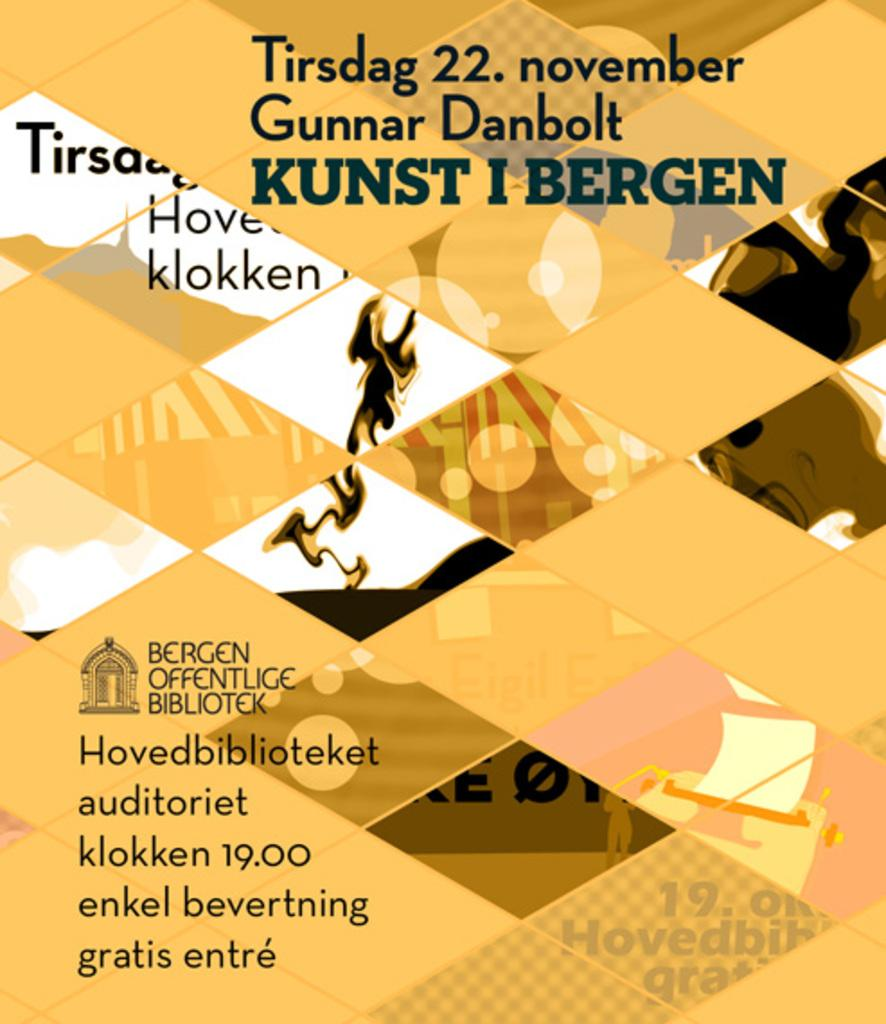<image>
Present a compact description of the photo's key features. A yellow promotional poster for Kunst I Bergen. 